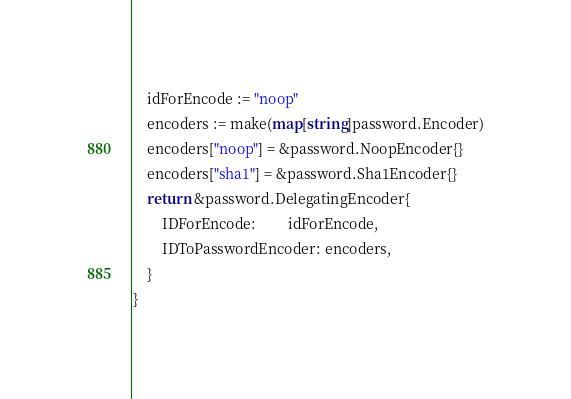<code> <loc_0><loc_0><loc_500><loc_500><_Go_>	idForEncode := "noop"
	encoders := make(map[string]password.Encoder)
	encoders["noop"] = &password.NoopEncoder{}
	encoders["sha1"] = &password.Sha1Encoder{}
	return &password.DelegatingEncoder{
		IDForEncode:         idForEncode,
		IDToPasswordEncoder: encoders,
	}
}
</code> 